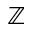<formula> <loc_0><loc_0><loc_500><loc_500>{ \mathbb { Z } }</formula> 